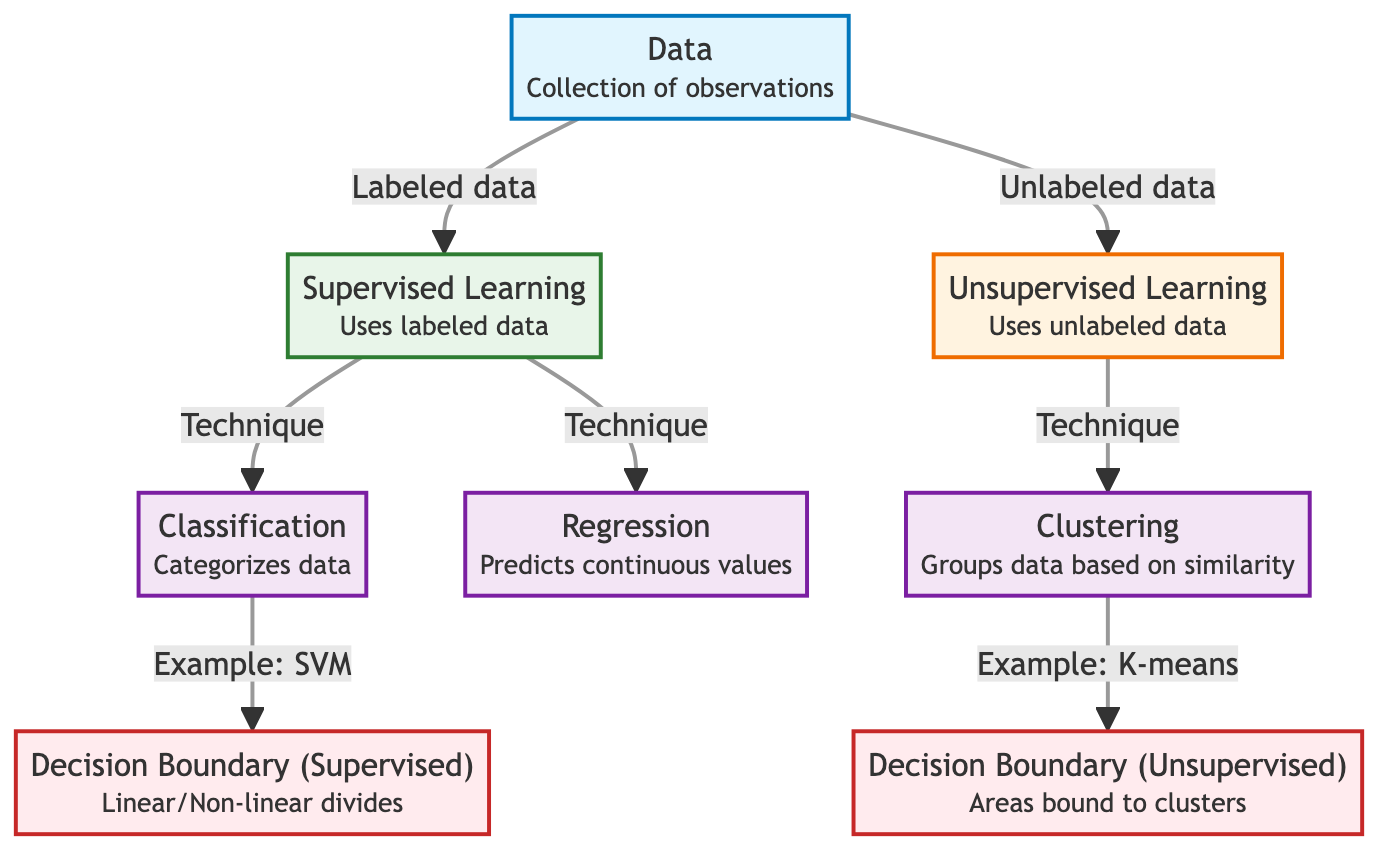What are the two main categories of learning in this diagram? The diagram shows two primary branches: "Supervised Learning" and "Unsupervised Learning." These are clearly illustrated, each with descriptions indicating their data usage.
Answer: Supervised Learning, Unsupervised Learning What technique is associated with supervised learning that predicts continuous values? The diagram specifies "Regression" as a technique under "Supervised Learning" that focuses on predicting continuous values. This is seen directly under the supervised learning node.
Answer: Regression How many techniques are illustrated under unsupervised learning? There is one listed technique under "Unsupervised Learning," which is "Clustering." The diagram directly connects the unsupervised node to this technique.
Answer: One What is the decision boundary type associated with the Supervised Learning technique? The diagram indicates that the decision boundary related to supervised learning is labeled "Decision Boundary (Supervised)," showing it can be linear or non-linear. This is clearly linked to the classification technique.
Answer: Linear/Non-linear Which supervised learning technique has an example provided in the diagram? The diagram provides an example of "SVM" under the "Classification" technique, clearly indicating it through a direct arrow and label.
Answer: SVM What label describes the data flow to supervised learning? The data flow leading to "Supervised Learning" is labeled "Labeled data," indicating that this type of learning relies on data that has been annotated with labels.
Answer: Labeled data Which example technique is given for the unsupervised learning approach? The diagram specifies "K-means" as the example technique for "Clustering" under "Unsupervised Learning," connecting both nodes directly.
Answer: K-means What type of boundary is illustrated for unsupervised learning? The diagram describes the boundary associated with unsupervised learning as "Decision Boundary (Unsupervised)," stating it represents areas bound to clusters. This label is seen linked to clustering.
Answer: Areas bound to clusters What are the two types of data represented in the diagram? The diagram indicates two types of data flowing into the learning nodes: one for "Labeled data," which connects to supervised learning, and another for "Unlabeled data," linking to unsupervised learning.
Answer: Labeled data, Unlabeled data 